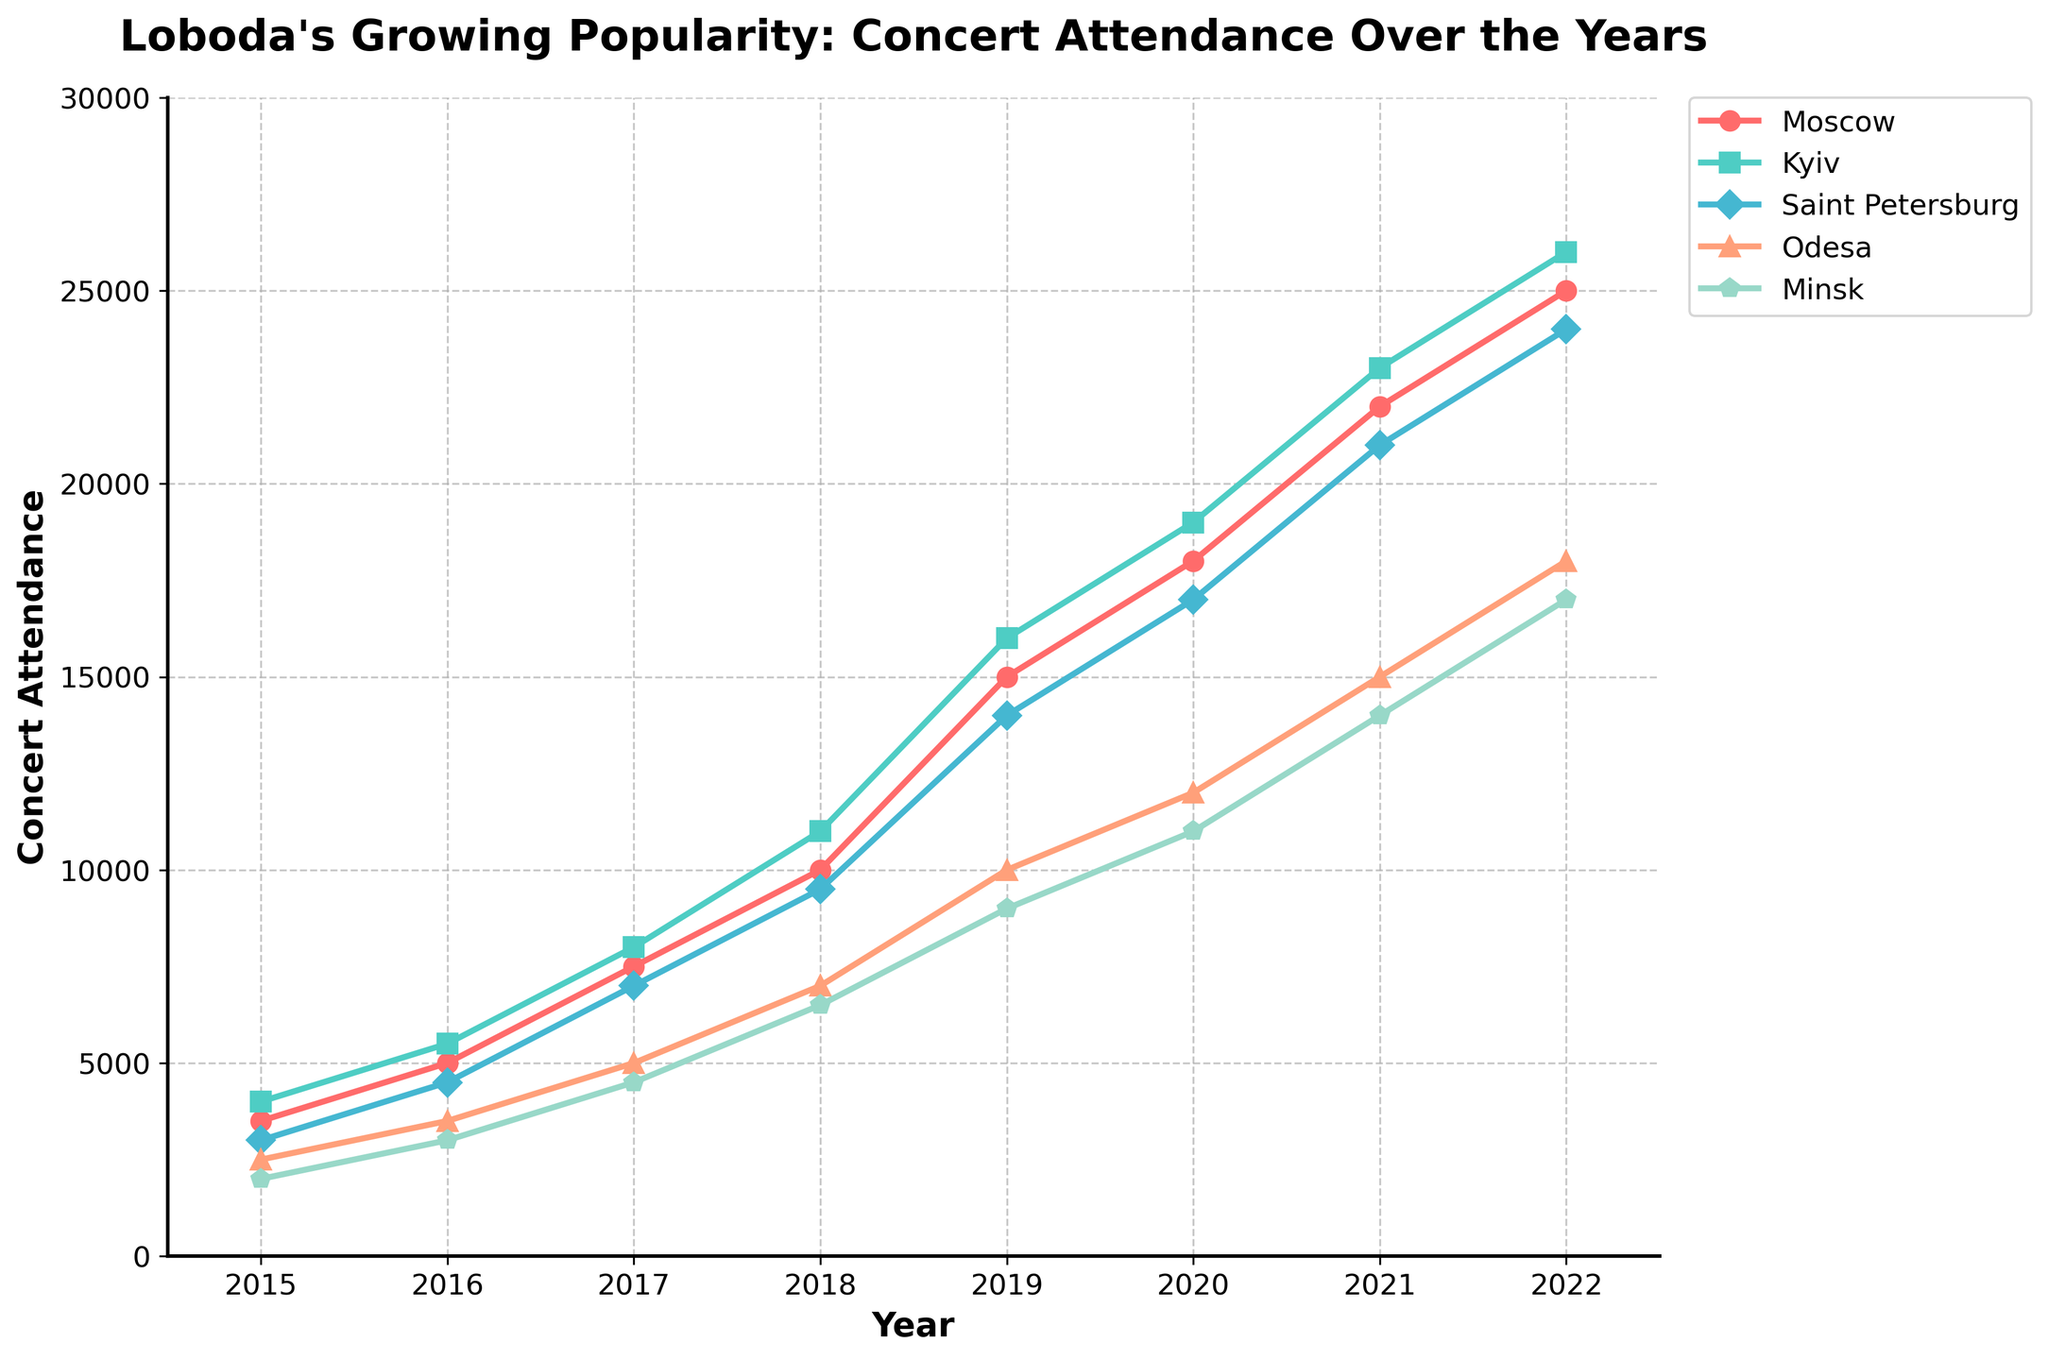What city had the highest concert attendance in 2022? To find the city with the highest concert attendance in 2022, look at the endpoints of the lines on the right side of the chart. The line for Kyiv peaks the highest in 2022.
Answer: Kyiv Compare the concert attendance growth between Moscow and Odesa from 2015 to 2022. Which city experienced more growth? Calculate the difference in concert attendance for both cities from 2015 to 2022. For Moscow, it's 25000 - 3500 = 21500; for Odesa, it's 18000 - 2500 = 15500. Moscow experienced greater growth.
Answer: Moscow Which year saw the highest relative increase in concert attendance for all cities? Look for the steepest slopes for all the lines, indicating the highest relative increase. The growth from 2015 to 2016 seems the highest relative increase based on the visual steepness of the slopes for multiple cities.
Answer: 2016 How many years did it take for Saint Petersburg's concert attendance to double from its 2015 figure? Saint Petersburg had 3000 attendees in 2015 and doubled to 6000. This occurred between 2015 to 2017.
Answer: 2 What is the average concert attendance in Minsk from 2015 to 2022? Sum the attendance figures for Minsk from 2015 to 2022: 2000 + 3000 + 4500 + 6500 + 9000 + 11000 + 14000 + 17000 = 67500. Divide by the 8 years: 67500 / 8 = 8437.5.
Answer: 8437.5 Compare the concert attendance in Kyiv in 2018 and Minsk in 2022. Which one is higher, and by how much? Kyiv's attendance in 2018 is 11000, and Minsk's in 2022 is 17000. Minsk's is higher by 17000 - 11000 = 6000.
Answer: Minsk by 6000 In which year did Moscow's concert attendance surpass 15000? Find where the Moscow line (red) crosses the 15000 mark. This happens in 2019.
Answer: 2019 How many cities had an attendance of at least 20000 in 2021? Check the line chart for 2021 and count the number of lines that are at or above 20000. These cities are Moscow, Kyiv, and Saint Petersburg.
Answer: 3 What's the total concert attendance for all cities combined in 2017? Sum the attendance figures for all cities in 2017: 7500 + 8000 + 7000 + 5000 + 4500 = 32000.
Answer: 32000 If Odesa’s concert attendance continues to grow at the same rate as from 2021 to 2022, what would be the expected attendance in 2023? Odesa’s attendance grew from 15000 in 2021 to 18000 in 2022, an increase of 3000. Therefore, the expected attendance in 2023 is 18000 + 3000 = 21000.
Answer: 21000 